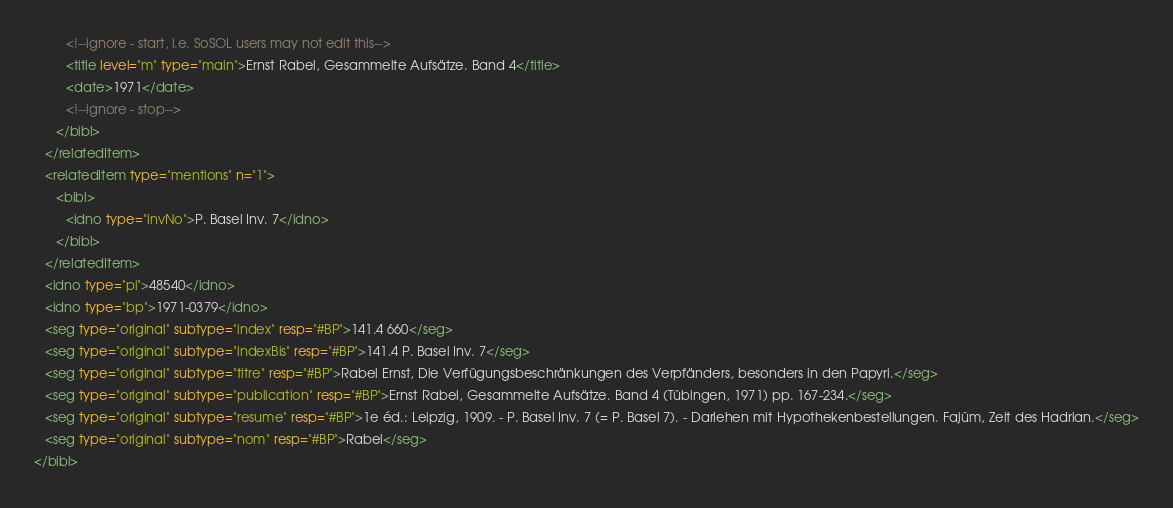<code> <loc_0><loc_0><loc_500><loc_500><_XML_>         <!--ignore - start, i.e. SoSOL users may not edit this-->
         <title level="m" type="main">Ernst Rabel, Gesammelte Aufsätze. Band 4</title>
         <date>1971</date>
         <!--ignore - stop-->
      </bibl>
   </relatedItem>
   <relatedItem type="mentions" n="1">
      <bibl>
         <idno type="invNo">P. Basel Inv. 7</idno>
      </bibl>
   </relatedItem>
   <idno type="pi">48540</idno>
   <idno type="bp">1971-0379</idno>
   <seg type="original" subtype="index" resp="#BP">141.4 660</seg>
   <seg type="original" subtype="indexBis" resp="#BP">141.4 P. Basel Inv. 7</seg>
   <seg type="original" subtype="titre" resp="#BP">Rabel Ernst, Die Verfügungsbeschränkungen des Verpfänders, besonders in den Papyri.</seg>
   <seg type="original" subtype="publication" resp="#BP">Ernst Rabel, Gesammelte Aufsätze. Band 4 (Tübingen, 1971) pp. 167-234.</seg>
   <seg type="original" subtype="resume" resp="#BP">1e éd.: Leipzig, 1909. - P. Basel Inv. 7 (= P. Basel 7). - Darlehen mit Hypothekenbestellungen. Fajûm, Zeit des Hadrian.</seg>
   <seg type="original" subtype="nom" resp="#BP">Rabel</seg>
</bibl>
</code> 